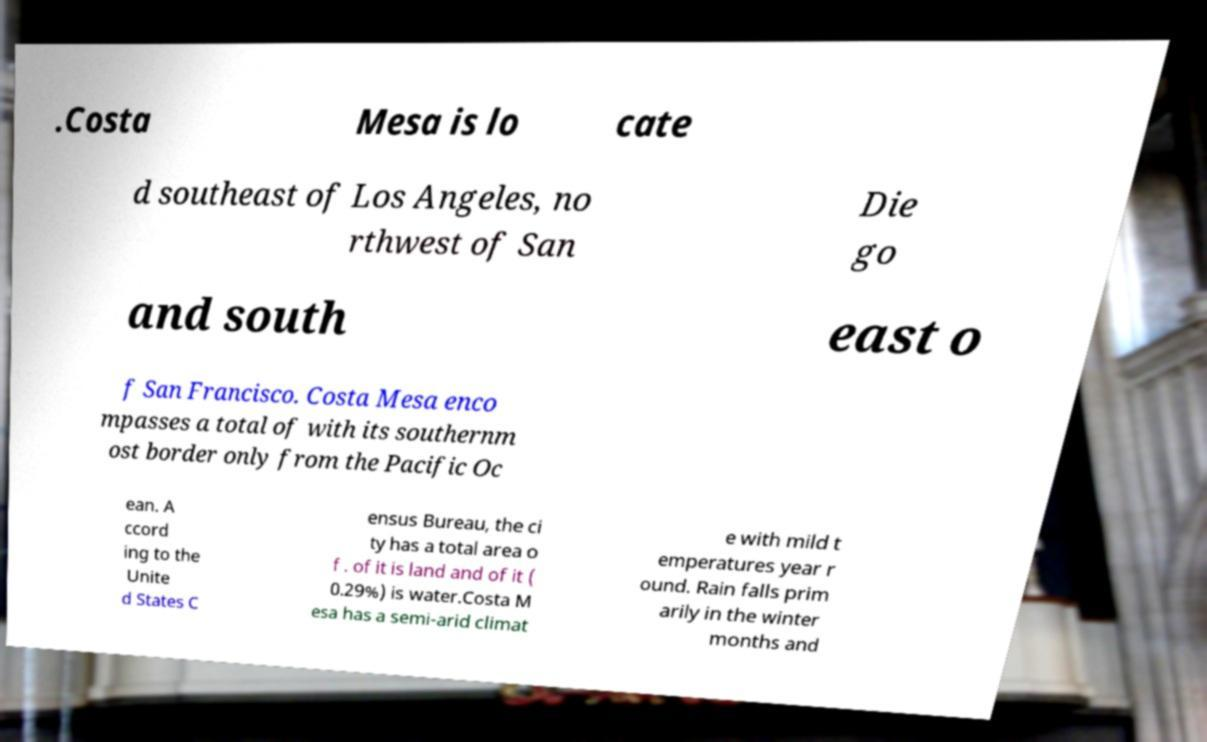Could you extract and type out the text from this image? .Costa Mesa is lo cate d southeast of Los Angeles, no rthwest of San Die go and south east o f San Francisco. Costa Mesa enco mpasses a total of with its southernm ost border only from the Pacific Oc ean. A ccord ing to the Unite d States C ensus Bureau, the ci ty has a total area o f . of it is land and of it ( 0.29%) is water.Costa M esa has a semi-arid climat e with mild t emperatures year r ound. Rain falls prim arily in the winter months and 